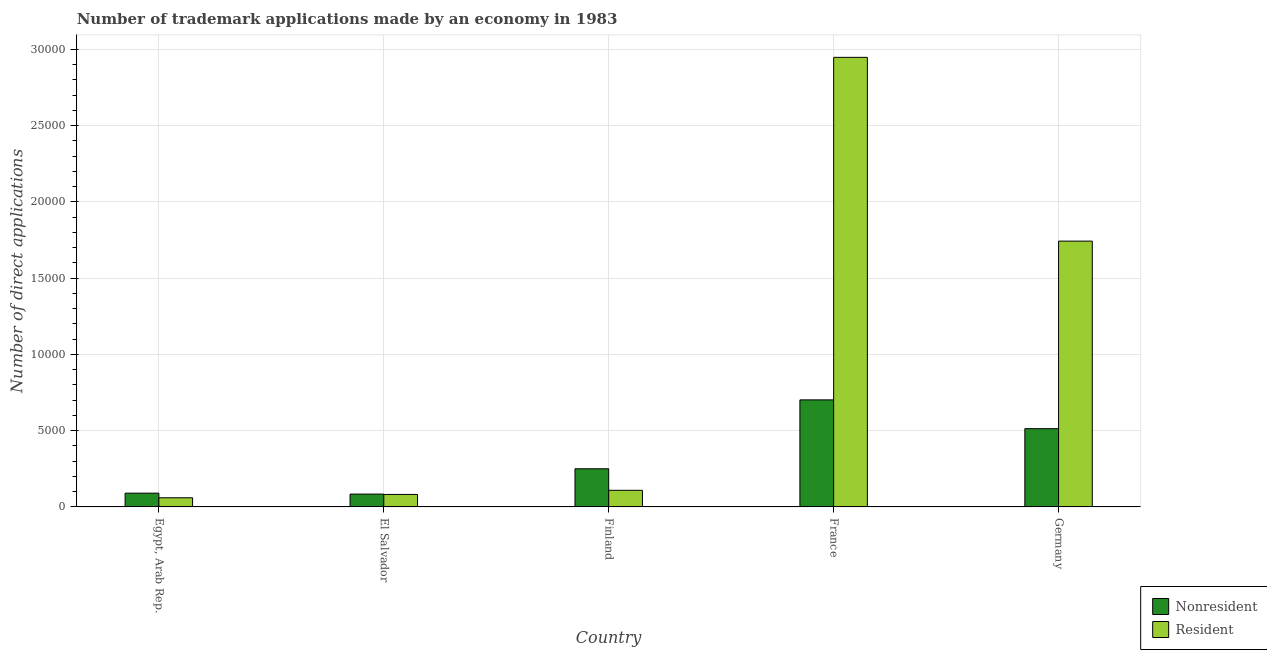How many groups of bars are there?
Keep it short and to the point. 5. What is the label of the 1st group of bars from the left?
Make the answer very short. Egypt, Arab Rep. In how many cases, is the number of bars for a given country not equal to the number of legend labels?
Your answer should be compact. 0. What is the number of trademark applications made by residents in France?
Provide a short and direct response. 2.95e+04. Across all countries, what is the maximum number of trademark applications made by non residents?
Offer a terse response. 7017. Across all countries, what is the minimum number of trademark applications made by non residents?
Provide a short and direct response. 842. In which country was the number of trademark applications made by non residents maximum?
Provide a short and direct response. France. In which country was the number of trademark applications made by residents minimum?
Provide a succinct answer. Egypt, Arab Rep. What is the total number of trademark applications made by non residents in the graph?
Keep it short and to the point. 1.64e+04. What is the difference between the number of trademark applications made by residents in Egypt, Arab Rep. and that in Finland?
Make the answer very short. -490. What is the difference between the number of trademark applications made by residents in Egypt, Arab Rep. and the number of trademark applications made by non residents in France?
Your response must be concise. -6417. What is the average number of trademark applications made by residents per country?
Make the answer very short. 9880.2. What is the difference between the number of trademark applications made by residents and number of trademark applications made by non residents in Egypt, Arab Rep.?
Your answer should be compact. -302. What is the ratio of the number of trademark applications made by non residents in Egypt, Arab Rep. to that in France?
Provide a short and direct response. 0.13. Is the number of trademark applications made by non residents in France less than that in Germany?
Make the answer very short. No. Is the difference between the number of trademark applications made by non residents in El Salvador and France greater than the difference between the number of trademark applications made by residents in El Salvador and France?
Keep it short and to the point. Yes. What is the difference between the highest and the second highest number of trademark applications made by residents?
Ensure brevity in your answer.  1.20e+04. What is the difference between the highest and the lowest number of trademark applications made by non residents?
Offer a terse response. 6175. Is the sum of the number of trademark applications made by residents in Finland and Germany greater than the maximum number of trademark applications made by non residents across all countries?
Ensure brevity in your answer.  Yes. What does the 1st bar from the left in Germany represents?
Your response must be concise. Nonresident. What does the 1st bar from the right in El Salvador represents?
Ensure brevity in your answer.  Resident. How many countries are there in the graph?
Your response must be concise. 5. Are the values on the major ticks of Y-axis written in scientific E-notation?
Your response must be concise. No. Does the graph contain grids?
Provide a short and direct response. Yes. Where does the legend appear in the graph?
Your answer should be very brief. Bottom right. How are the legend labels stacked?
Make the answer very short. Vertical. What is the title of the graph?
Your answer should be compact. Number of trademark applications made by an economy in 1983. Does "Non-pregnant women" appear as one of the legend labels in the graph?
Offer a very short reply. No. What is the label or title of the X-axis?
Your response must be concise. Country. What is the label or title of the Y-axis?
Offer a terse response. Number of direct applications. What is the Number of direct applications in Nonresident in Egypt, Arab Rep.?
Keep it short and to the point. 902. What is the Number of direct applications in Resident in Egypt, Arab Rep.?
Your answer should be compact. 600. What is the Number of direct applications in Nonresident in El Salvador?
Ensure brevity in your answer.  842. What is the Number of direct applications of Resident in El Salvador?
Your answer should be compact. 818. What is the Number of direct applications of Nonresident in Finland?
Ensure brevity in your answer.  2501. What is the Number of direct applications of Resident in Finland?
Provide a short and direct response. 1090. What is the Number of direct applications of Nonresident in France?
Provide a short and direct response. 7017. What is the Number of direct applications in Resident in France?
Offer a very short reply. 2.95e+04. What is the Number of direct applications in Nonresident in Germany?
Provide a succinct answer. 5130. What is the Number of direct applications of Resident in Germany?
Keep it short and to the point. 1.74e+04. Across all countries, what is the maximum Number of direct applications of Nonresident?
Offer a terse response. 7017. Across all countries, what is the maximum Number of direct applications in Resident?
Make the answer very short. 2.95e+04. Across all countries, what is the minimum Number of direct applications in Nonresident?
Your answer should be very brief. 842. Across all countries, what is the minimum Number of direct applications in Resident?
Provide a succinct answer. 600. What is the total Number of direct applications in Nonresident in the graph?
Give a very brief answer. 1.64e+04. What is the total Number of direct applications in Resident in the graph?
Provide a short and direct response. 4.94e+04. What is the difference between the Number of direct applications in Nonresident in Egypt, Arab Rep. and that in El Salvador?
Your answer should be very brief. 60. What is the difference between the Number of direct applications of Resident in Egypt, Arab Rep. and that in El Salvador?
Give a very brief answer. -218. What is the difference between the Number of direct applications in Nonresident in Egypt, Arab Rep. and that in Finland?
Offer a very short reply. -1599. What is the difference between the Number of direct applications of Resident in Egypt, Arab Rep. and that in Finland?
Offer a terse response. -490. What is the difference between the Number of direct applications in Nonresident in Egypt, Arab Rep. and that in France?
Offer a very short reply. -6115. What is the difference between the Number of direct applications in Resident in Egypt, Arab Rep. and that in France?
Your answer should be compact. -2.89e+04. What is the difference between the Number of direct applications in Nonresident in Egypt, Arab Rep. and that in Germany?
Give a very brief answer. -4228. What is the difference between the Number of direct applications of Resident in Egypt, Arab Rep. and that in Germany?
Keep it short and to the point. -1.68e+04. What is the difference between the Number of direct applications of Nonresident in El Salvador and that in Finland?
Provide a short and direct response. -1659. What is the difference between the Number of direct applications of Resident in El Salvador and that in Finland?
Offer a terse response. -272. What is the difference between the Number of direct applications in Nonresident in El Salvador and that in France?
Provide a short and direct response. -6175. What is the difference between the Number of direct applications in Resident in El Salvador and that in France?
Ensure brevity in your answer.  -2.87e+04. What is the difference between the Number of direct applications of Nonresident in El Salvador and that in Germany?
Your answer should be compact. -4288. What is the difference between the Number of direct applications in Resident in El Salvador and that in Germany?
Ensure brevity in your answer.  -1.66e+04. What is the difference between the Number of direct applications of Nonresident in Finland and that in France?
Provide a succinct answer. -4516. What is the difference between the Number of direct applications of Resident in Finland and that in France?
Provide a short and direct response. -2.84e+04. What is the difference between the Number of direct applications of Nonresident in Finland and that in Germany?
Make the answer very short. -2629. What is the difference between the Number of direct applications in Resident in Finland and that in Germany?
Offer a terse response. -1.63e+04. What is the difference between the Number of direct applications of Nonresident in France and that in Germany?
Offer a very short reply. 1887. What is the difference between the Number of direct applications in Resident in France and that in Germany?
Keep it short and to the point. 1.20e+04. What is the difference between the Number of direct applications of Nonresident in Egypt, Arab Rep. and the Number of direct applications of Resident in Finland?
Offer a very short reply. -188. What is the difference between the Number of direct applications in Nonresident in Egypt, Arab Rep. and the Number of direct applications in Resident in France?
Your response must be concise. -2.86e+04. What is the difference between the Number of direct applications in Nonresident in Egypt, Arab Rep. and the Number of direct applications in Resident in Germany?
Keep it short and to the point. -1.65e+04. What is the difference between the Number of direct applications of Nonresident in El Salvador and the Number of direct applications of Resident in Finland?
Provide a succinct answer. -248. What is the difference between the Number of direct applications of Nonresident in El Salvador and the Number of direct applications of Resident in France?
Give a very brief answer. -2.86e+04. What is the difference between the Number of direct applications in Nonresident in El Salvador and the Number of direct applications in Resident in Germany?
Give a very brief answer. -1.66e+04. What is the difference between the Number of direct applications in Nonresident in Finland and the Number of direct applications in Resident in France?
Give a very brief answer. -2.70e+04. What is the difference between the Number of direct applications of Nonresident in Finland and the Number of direct applications of Resident in Germany?
Your answer should be very brief. -1.49e+04. What is the difference between the Number of direct applications in Nonresident in France and the Number of direct applications in Resident in Germany?
Your answer should be compact. -1.04e+04. What is the average Number of direct applications in Nonresident per country?
Provide a short and direct response. 3278.4. What is the average Number of direct applications in Resident per country?
Keep it short and to the point. 9880.2. What is the difference between the Number of direct applications of Nonresident and Number of direct applications of Resident in Egypt, Arab Rep.?
Your answer should be very brief. 302. What is the difference between the Number of direct applications of Nonresident and Number of direct applications of Resident in El Salvador?
Your answer should be compact. 24. What is the difference between the Number of direct applications in Nonresident and Number of direct applications in Resident in Finland?
Your answer should be very brief. 1411. What is the difference between the Number of direct applications of Nonresident and Number of direct applications of Resident in France?
Your response must be concise. -2.25e+04. What is the difference between the Number of direct applications of Nonresident and Number of direct applications of Resident in Germany?
Your answer should be compact. -1.23e+04. What is the ratio of the Number of direct applications in Nonresident in Egypt, Arab Rep. to that in El Salvador?
Keep it short and to the point. 1.07. What is the ratio of the Number of direct applications of Resident in Egypt, Arab Rep. to that in El Salvador?
Make the answer very short. 0.73. What is the ratio of the Number of direct applications of Nonresident in Egypt, Arab Rep. to that in Finland?
Give a very brief answer. 0.36. What is the ratio of the Number of direct applications in Resident in Egypt, Arab Rep. to that in Finland?
Make the answer very short. 0.55. What is the ratio of the Number of direct applications in Nonresident in Egypt, Arab Rep. to that in France?
Provide a succinct answer. 0.13. What is the ratio of the Number of direct applications of Resident in Egypt, Arab Rep. to that in France?
Your answer should be very brief. 0.02. What is the ratio of the Number of direct applications in Nonresident in Egypt, Arab Rep. to that in Germany?
Offer a terse response. 0.18. What is the ratio of the Number of direct applications of Resident in Egypt, Arab Rep. to that in Germany?
Your response must be concise. 0.03. What is the ratio of the Number of direct applications of Nonresident in El Salvador to that in Finland?
Your response must be concise. 0.34. What is the ratio of the Number of direct applications of Resident in El Salvador to that in Finland?
Your response must be concise. 0.75. What is the ratio of the Number of direct applications in Nonresident in El Salvador to that in France?
Ensure brevity in your answer.  0.12. What is the ratio of the Number of direct applications in Resident in El Salvador to that in France?
Offer a very short reply. 0.03. What is the ratio of the Number of direct applications in Nonresident in El Salvador to that in Germany?
Ensure brevity in your answer.  0.16. What is the ratio of the Number of direct applications of Resident in El Salvador to that in Germany?
Keep it short and to the point. 0.05. What is the ratio of the Number of direct applications in Nonresident in Finland to that in France?
Keep it short and to the point. 0.36. What is the ratio of the Number of direct applications in Resident in Finland to that in France?
Make the answer very short. 0.04. What is the ratio of the Number of direct applications in Nonresident in Finland to that in Germany?
Offer a terse response. 0.49. What is the ratio of the Number of direct applications in Resident in Finland to that in Germany?
Offer a terse response. 0.06. What is the ratio of the Number of direct applications in Nonresident in France to that in Germany?
Provide a succinct answer. 1.37. What is the ratio of the Number of direct applications in Resident in France to that in Germany?
Give a very brief answer. 1.69. What is the difference between the highest and the second highest Number of direct applications of Nonresident?
Provide a succinct answer. 1887. What is the difference between the highest and the second highest Number of direct applications in Resident?
Provide a succinct answer. 1.20e+04. What is the difference between the highest and the lowest Number of direct applications of Nonresident?
Your answer should be compact. 6175. What is the difference between the highest and the lowest Number of direct applications of Resident?
Provide a succinct answer. 2.89e+04. 